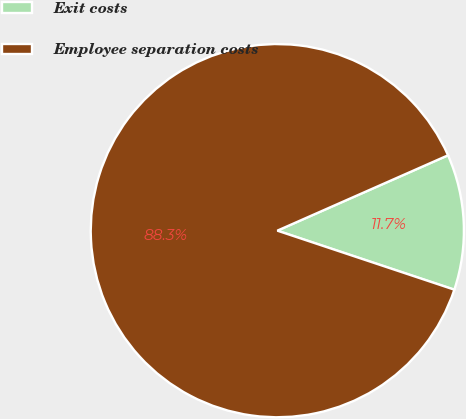<chart> <loc_0><loc_0><loc_500><loc_500><pie_chart><fcel>Exit costs<fcel>Employee separation costs<nl><fcel>11.74%<fcel>88.26%<nl></chart> 